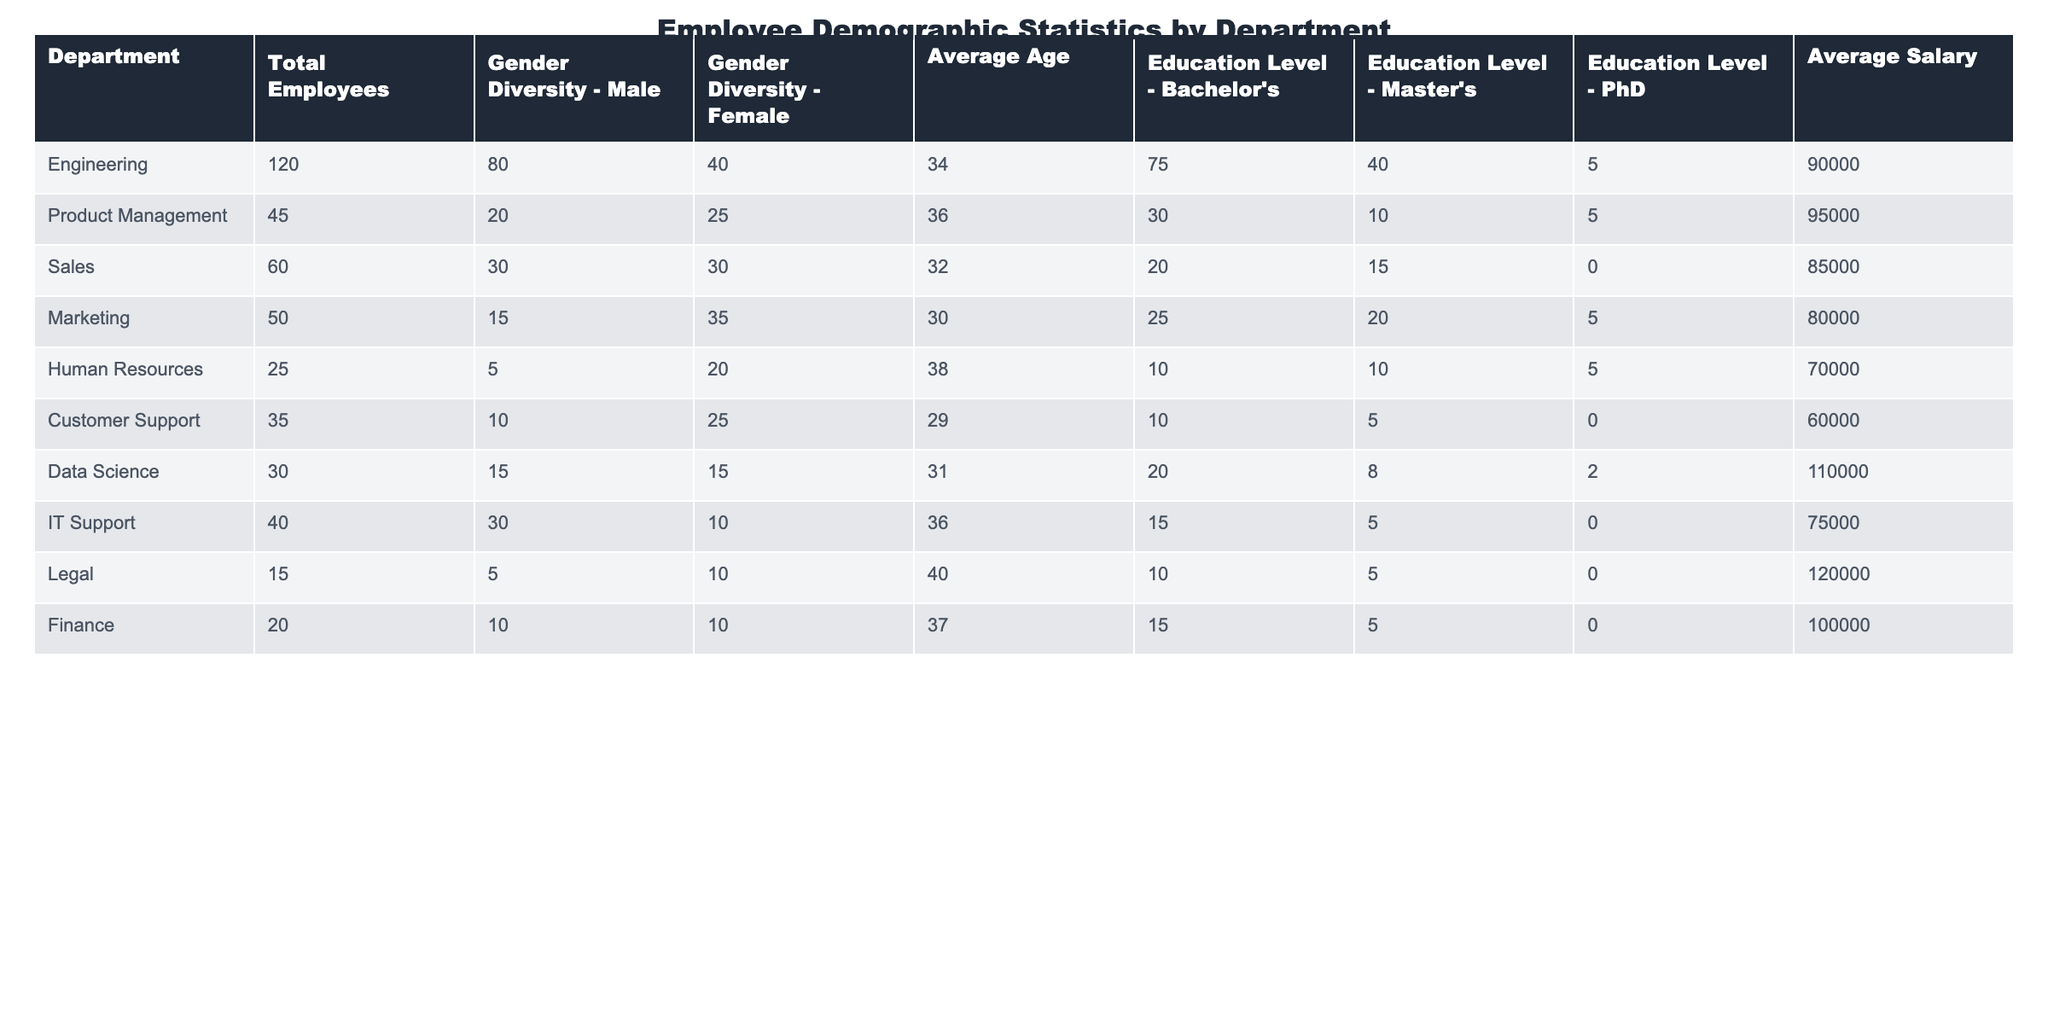What is the average salary of employees in the Engineering department? The average salary for the Engineering department is provided directly in the table under the 'Average Salary' column, which shows $90,000.
Answer: $90,000 How many female employees are there in the Product Management department? From the 'Gender Diversity - Female' column for Product Management, the value is 25, indicating the number of female employees.
Answer: 25 Which department has the highest average age among its employees? The 'Average Age' column shows that the Human Resources department has the highest average age at 38 years.
Answer: 38 Is there a department with no employees holding a PhD? Checking the 'Education Level - PhD' column, we can see that the Sales, Marketing, Customer Support, IT Support, and Legal departments have 0 PhD employees. Thus, the statement is true.
Answer: Yes What is the total number of male employees across all departments? To find the total number of male employees, sum the values from the 'Gender Diversity - Male' column: 80 + 20 + 30 + 15 + 5 + 10 + 15 + 30 + 5 + 10 = 220.
Answer: 220 Which department has the least number of total employees? By comparing the 'Total Employees' column, Human Resources shows the least number at 25.
Answer: 25 Which department has the highest male employee percentage? Calculate the percentage of male employees by dividing the male employees by total employees for each department. The Engineering department has the highest percentage: (80/120)*100 = 66.67%.
Answer: Engineering What is the average salary for departments that have a Master's education level? For departments with Master's degrees, we check their average salaries: Product Management ($95,000), Marketing ($80,000), Human Resources ($70,000), Data Science ($110,000), Finance ($100,000). The total average salary is: (95000 + 80000 + 70000 + 110000 + 100000)/5 = $92,000.
Answer: $92,000 Are there more departments with an average salary above $90,000 or below $90,000? Listing the average salaries: Engineering ($90,000), Product Management ($95,000), Sales ($85,000), Marketing ($80,000), Human Resources ($70,000), Customer Support ($60,000), Data Science ($110,000), IT Support ($75,000), Legal ($120,000), Finance ($100,000). Count shows 5 above and 5 below. Thus, they are equal.
Answer: Equal What is the average age of employees in departments with more than 50 total employees? Calculate the average ages of Engineering (34), Sales (32), Marketing (30), and IT Support (36) for those with more than 50 employees. Their average is: (34 + 32 + 30 + 36) / 4 = 33.
Answer: 33 